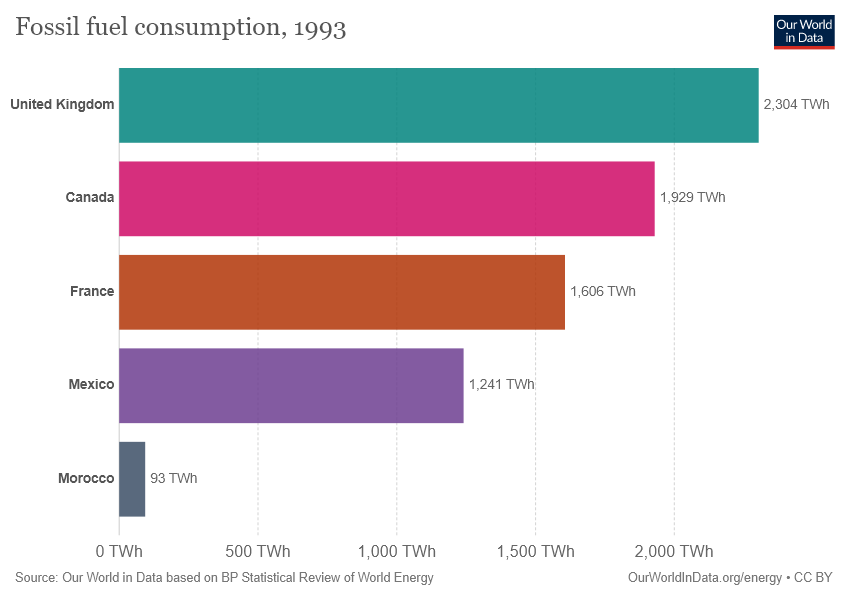Draw attention to some important aspects in this diagram. The sum of fossil fuel consumption in Mexico and Morocco was less than that of France as of 1993. In 1993, the United Kingdom consumed approximately 2,304 terawatt-hours of fossil fuels. 